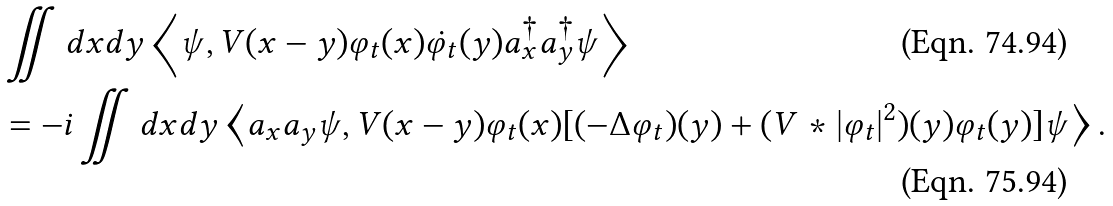<formula> <loc_0><loc_0><loc_500><loc_500>& \iint d x d y \left \langle \psi , V ( x - y ) \varphi _ { t } ( x ) \dot { \varphi _ { t } } ( y ) a _ { x } ^ { \dag } a _ { y } ^ { \dag } \psi \right \rangle \\ & = - i \iint d x d y \left \langle a _ { x } a _ { y } \psi , V ( x - y ) \varphi _ { t } ( x ) [ ( - \Delta \varphi _ { t } ) ( y ) + ( V * | \varphi _ { t } | ^ { 2 } ) ( y ) \varphi _ { t } ( y ) ] \psi \right \rangle .</formula> 